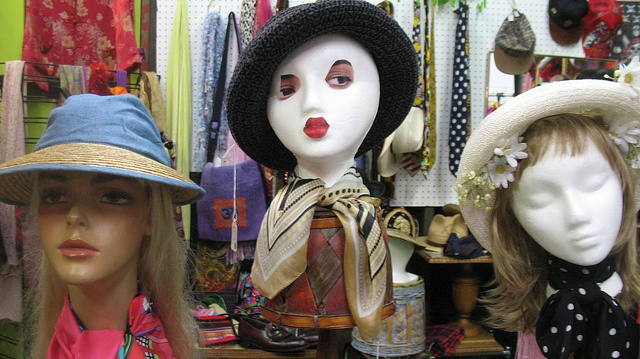Describe the objects in this image and their specific colors. I can see people in khaki, maroon, black, and gray tones, tie in khaki, black, darkgray, gray, and darkgreen tones, handbag in khaki, black, purple, and navy tones, tie in khaki, darkgray, tan, olive, and gray tones, and tie in khaki, darkgray, tan, gray, and lightgray tones in this image. 